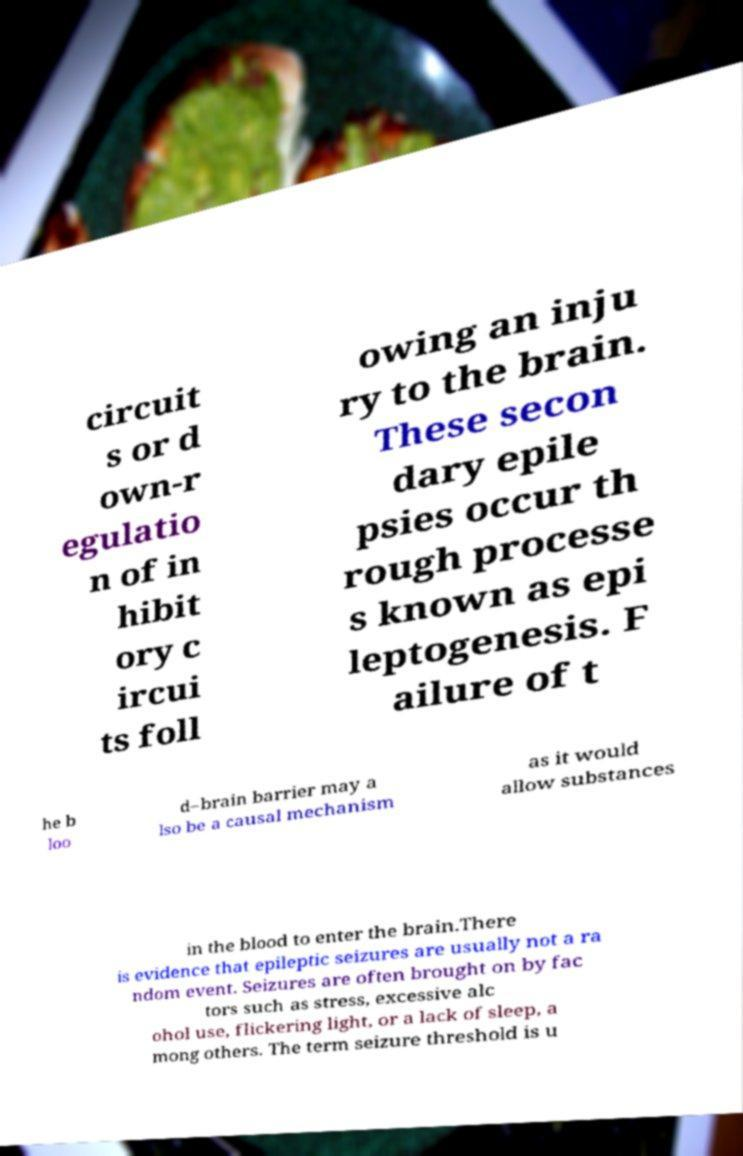Could you extract and type out the text from this image? circuit s or d own-r egulatio n of in hibit ory c ircui ts foll owing an inju ry to the brain. These secon dary epile psies occur th rough processe s known as epi leptogenesis. F ailure of t he b loo d–brain barrier may a lso be a causal mechanism as it would allow substances in the blood to enter the brain.There is evidence that epileptic seizures are usually not a ra ndom event. Seizures are often brought on by fac tors such as stress, excessive alc ohol use, flickering light, or a lack of sleep, a mong others. The term seizure threshold is u 